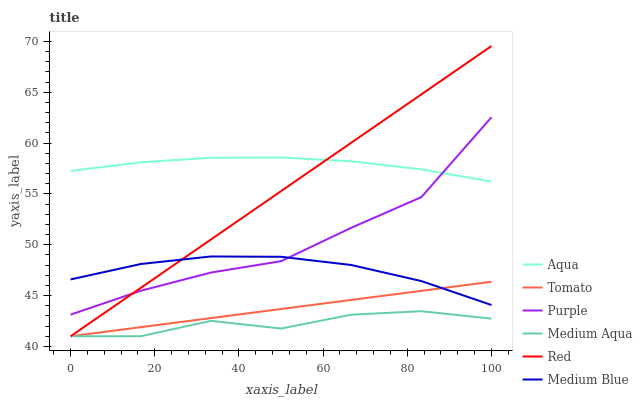Does Medium Aqua have the minimum area under the curve?
Answer yes or no. Yes. Does Aqua have the maximum area under the curve?
Answer yes or no. Yes. Does Purple have the minimum area under the curve?
Answer yes or no. No. Does Purple have the maximum area under the curve?
Answer yes or no. No. Is Tomato the smoothest?
Answer yes or no. Yes. Is Purple the roughest?
Answer yes or no. Yes. Is Medium Blue the smoothest?
Answer yes or no. No. Is Medium Blue the roughest?
Answer yes or no. No. Does Tomato have the lowest value?
Answer yes or no. Yes. Does Purple have the lowest value?
Answer yes or no. No. Does Red have the highest value?
Answer yes or no. Yes. Does Purple have the highest value?
Answer yes or no. No. Is Medium Blue less than Aqua?
Answer yes or no. Yes. Is Purple greater than Medium Aqua?
Answer yes or no. Yes. Does Aqua intersect Purple?
Answer yes or no. Yes. Is Aqua less than Purple?
Answer yes or no. No. Is Aqua greater than Purple?
Answer yes or no. No. Does Medium Blue intersect Aqua?
Answer yes or no. No. 